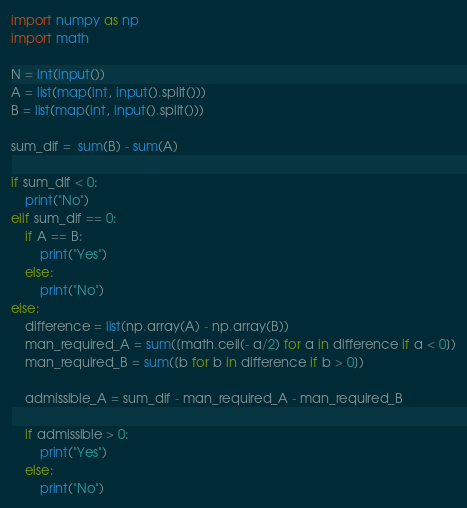Convert code to text. <code><loc_0><loc_0><loc_500><loc_500><_Python_>import numpy as np
import math

N = int(input())
A = list(map(int, input().split()))
B = list(map(int, input().split()))

sum_dif =  sum(B) - sum(A)

if sum_dif < 0:
    print("No")
elif sum_dif == 0:
    if A == B:
        print("Yes")
    else:
        print("No")
else:
    difference = list(np.array(A) - np.array(B))
    man_required_A = sum([math.ceil(- a/2) for a in difference if a < 0])
    man_required_B = sum([b for b in difference if b > 0])
    
    admissible_A = sum_dif - man_required_A - man_required_B
    
    if admissible > 0:
        print("Yes")
    else:
        print("No")</code> 